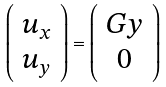<formula> <loc_0><loc_0><loc_500><loc_500>\left ( \begin{array} { c } u _ { x } \\ u _ { y } \end{array} \right ) = \left ( \begin{array} { c } G y \\ 0 \end{array} \right )</formula> 